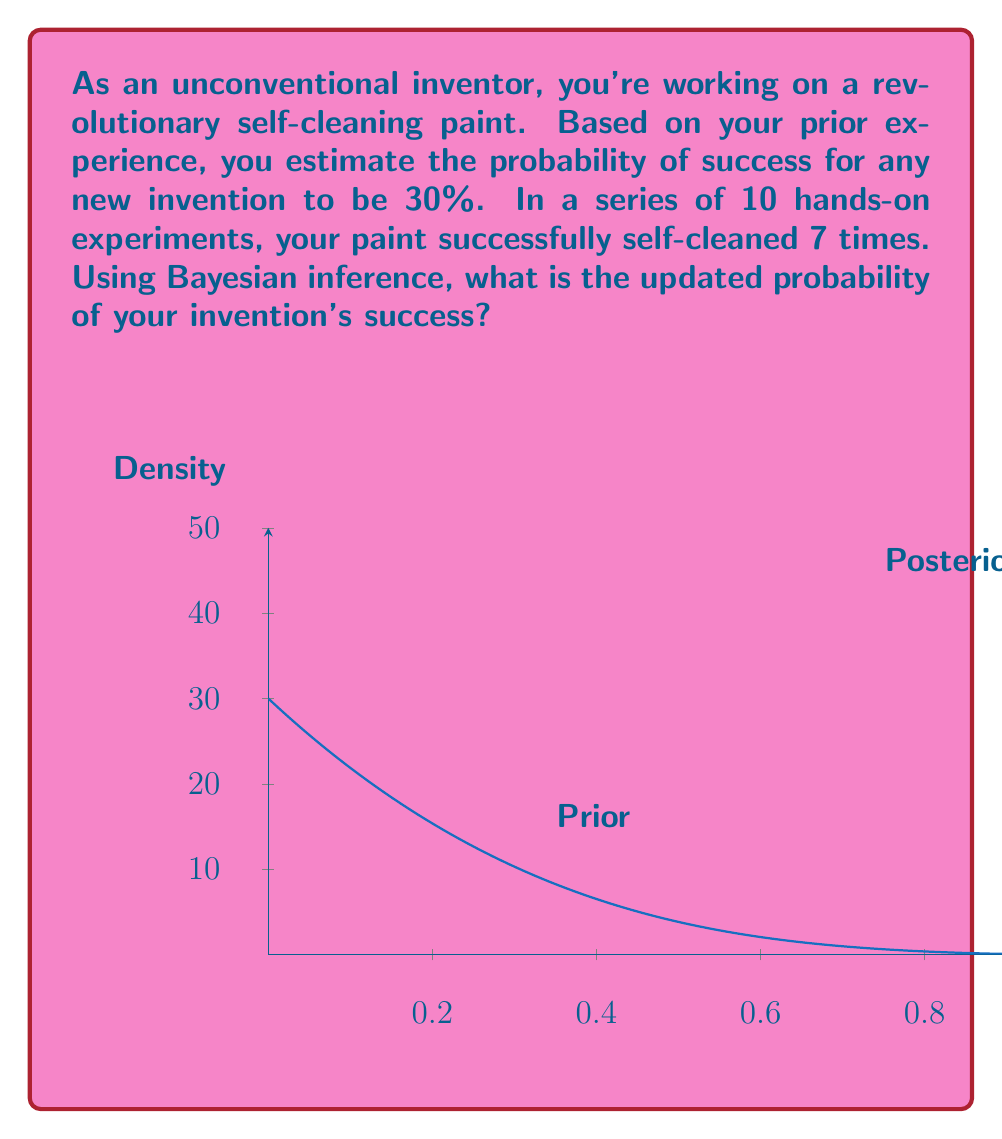Can you answer this question? Let's approach this step-by-step using Bayes' theorem:

1) Define our variables:
   $P(S)$ = Prior probability of success = 0.30
   $P(E|S)$ = Probability of the evidence given success
   $P(E)$ = Overall probability of the evidence

2) Our evidence is 7 successes out of 10 trials. This follows a binomial distribution:

   $P(E|S) = \binom{10}{7} S^7 (1-S)^3$

3) We need to calculate $P(E)$:

   $P(E) = P(E|S)P(S) + P(E|F)P(F)$
   
   where $F$ is failure, and $P(F) = 1 - P(S) = 0.70$

4) Plug into Bayes' theorem:

   $P(S|E) = \frac{P(E|S)P(S)}{P(E)}$

   $= \frac{\binom{10}{7} S^7 (1-S)^3 \cdot 0.30}{\binom{10}{7} S^7 (1-S)^3 \cdot 0.30 + \binom{10}{7} F^7 (1-F)^3 \cdot 0.70}$

5) Simplify:

   $P(S|E) = \frac{0.30 \cdot S^7 (1-S)^3}{0.30 \cdot S^7 (1-S)^3 + 0.70 \cdot F^7 (1-F)^3}$

6) Substitute $S = 0.30$ and $F = 0.70$:

   $P(S|E) = \frac{0.30 \cdot 0.30^7 \cdot 0.70^3}{0.30 \cdot 0.30^7 \cdot 0.70^3 + 0.70 \cdot 0.70^7 \cdot 0.30^3}$

7) Calculate:

   $P(S|E) \approx 0.7027$

Thus, the updated probability of success is approximately 70.27%.
Answer: $\approx 70.27\%$ 